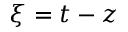<formula> <loc_0><loc_0><loc_500><loc_500>\xi = t - z</formula> 